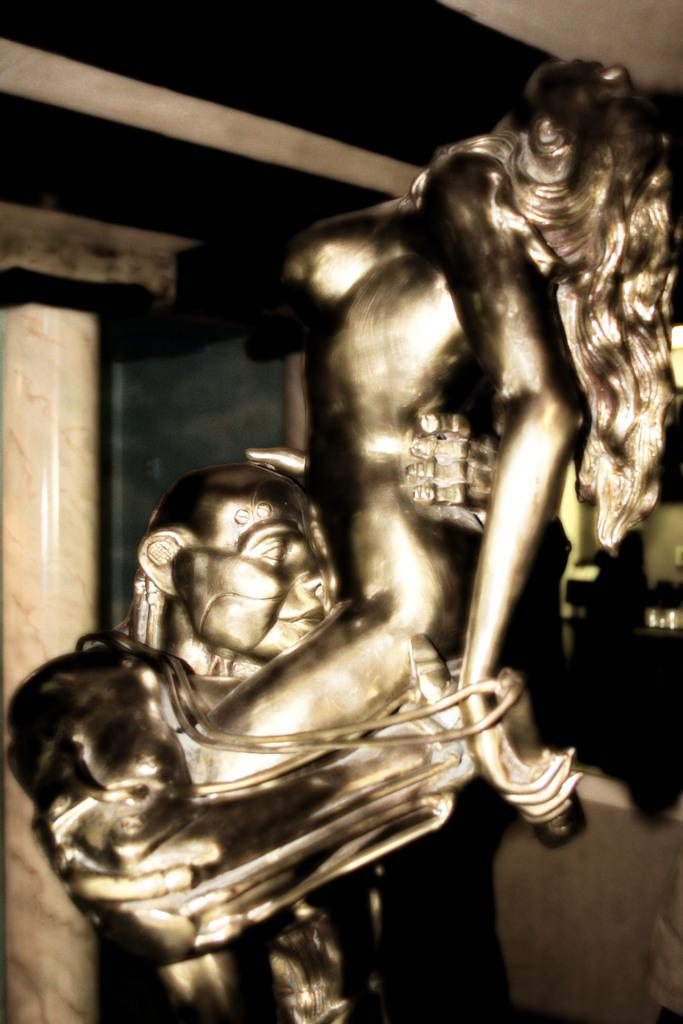What is the main subject of the image? The main subject of the image is a sculpture of two people. What is the relationship between the two people in the sculpture? One person is holding the other person in the sculpture. What can be seen in the background of the image? There is a pillar and a wall in the background of the image. How many ducks are sitting on the bed in the image? There are no ducks or beds present in the image; it features a sculpture of two people with a background of a pillar and a wall. 